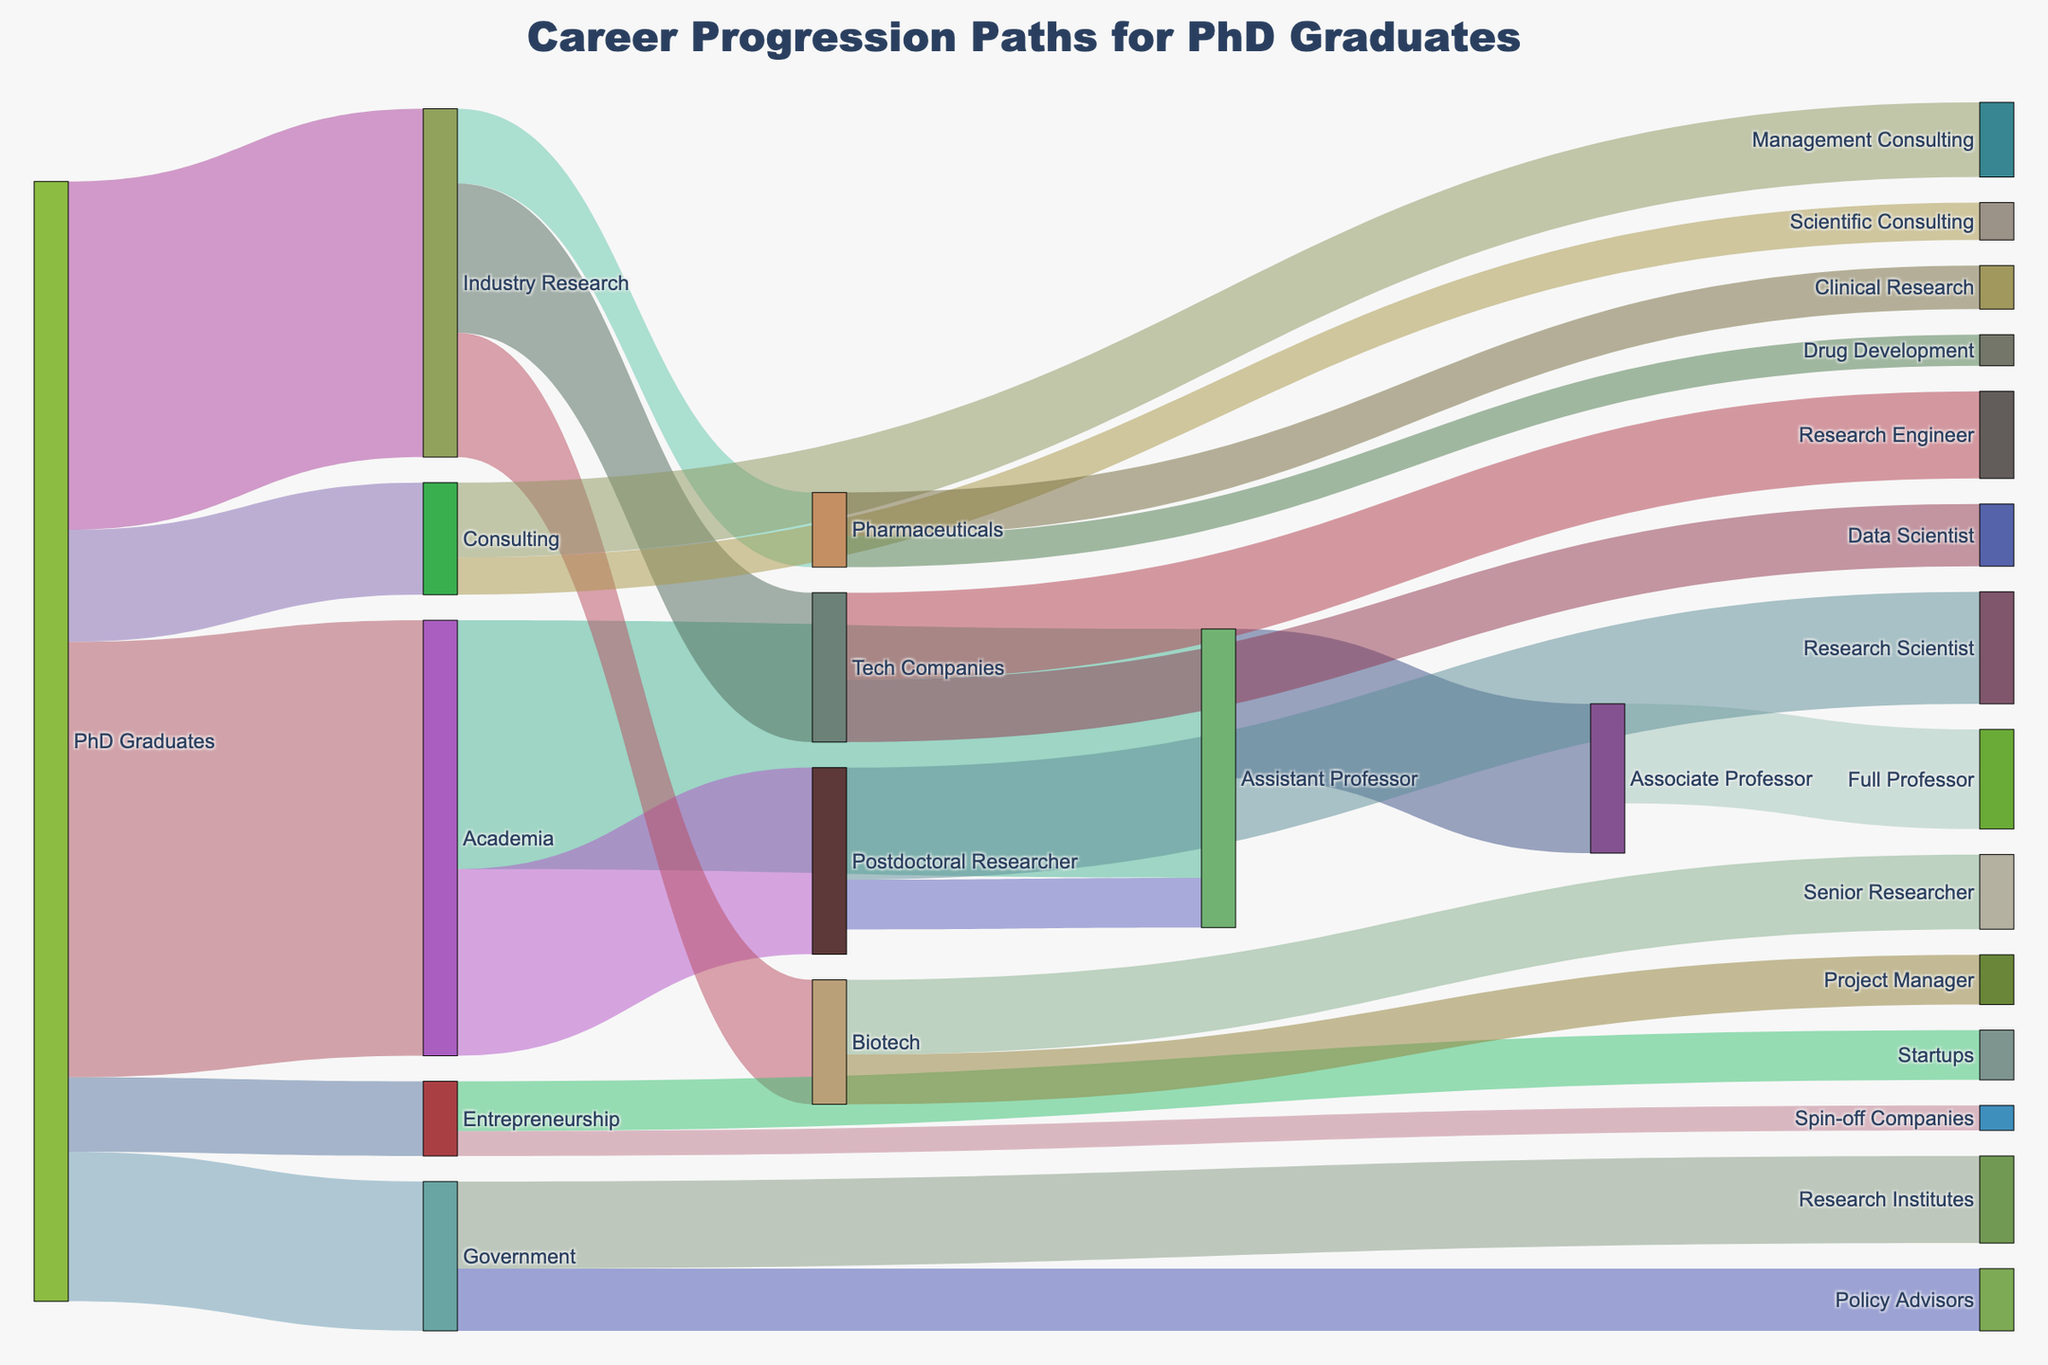What is the total number of PhD graduates represented in the diagram? Sum all the initial values originating from "PhD Graduates": 350 (Academia) + 280 (Industry Research) + 120 (Government) + 90 (Consulting) + 60 (Entrepreneurship) = 900
Answer: 900 Which career path has the highest number of PhD graduates? Compare the initial distribution values originating from "PhD Graduates": Academia (350), Industry Research (280), Government (120), Consulting (90), and Entrepreneurship (60). Academia has the highest number.
Answer: Academia In which sector do most postdoctoral researchers transition to an Assistant Professor role? Look at the transitions from "Postdoctoral Researcher" to identify the destination sectors: "Research Scientist" (90) and "Assistant Professor" (40). The specific comparison shows that a notable number move to Assistant Professor positions.
Answer: Assistant Professor Between "Tech Companies" and "Biotech" in Industry Research, which sector has more PhD graduates? Compare the number of graduates in each sector within Industry Research: "Tech Companies" (120) and "Biotech" (100). Tech Companies have more PhD graduates.
Answer: Tech Companies What is the total number of PhD graduates that remain in Academia as they progress in their career? Sum the values of graduates transitioning within Academia: "Assistant Professor" (200) transitions to either "Associate Professor" (120) or comes from "Postdoctoral Researcher" (40), and "Associate Professor" to "Full Professor" (80). Total within Academia = 200 + 120 + 80 = 400
Answer: 400 What proportion of the total PhD graduates pursue a career in Government as Policy Advisors? First, find the total number of PhD graduates (900), and then identify those pursuing careers in "Government" ("Policy Advisors" is 50). Calculate the proportion: (50/900) x 100 = 5.56%
Answer: 5.56% How many PhD graduates move into higher academic positions after becoming Assistant Professors? Calculate the sum of PhD graduates transitioning from "Assistant Professor" to higher positions: "Associate Professor" (120) and others. Total = 120
Answer: 120 Which is the smallest career transition flow depicted in the diagram? Identify the smallest transition by comparing all transition values:
"Spin-off Companies" (20) in Entrepreneurship sector.
Answer: Spin-off Companies How does the number of graduates transitioning from Assistant Professor to Associate Professor compare with those transitioning from Postdoctoral Researcher to Assistant Professor? Compare the values of transitions: "Assistant Professor" to "Associate Professor" (120) and "Postdoctoral Research" to "Assistant Professor" (40). The former is larger by 80.
Answer: 120 is larger by 80 What percentage of PhD graduates in Industry Research pursue Data Scientist roles in Tech Companies? Identify the total PhD graduates in Industry Research (280), and those moving to "Data Scientist" roles (50). Calculate the percentage: (50/280) x 100 = 17.86%
Answer: 17.86% 